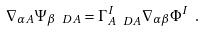Convert formula to latex. <formula><loc_0><loc_0><loc_500><loc_500>\nabla _ { \alpha A } \Psi _ { \beta \ D { A } } = \Gamma ^ { I } _ { A \ D { A } } \nabla _ { \alpha \beta } \Phi ^ { I } \ .</formula> 